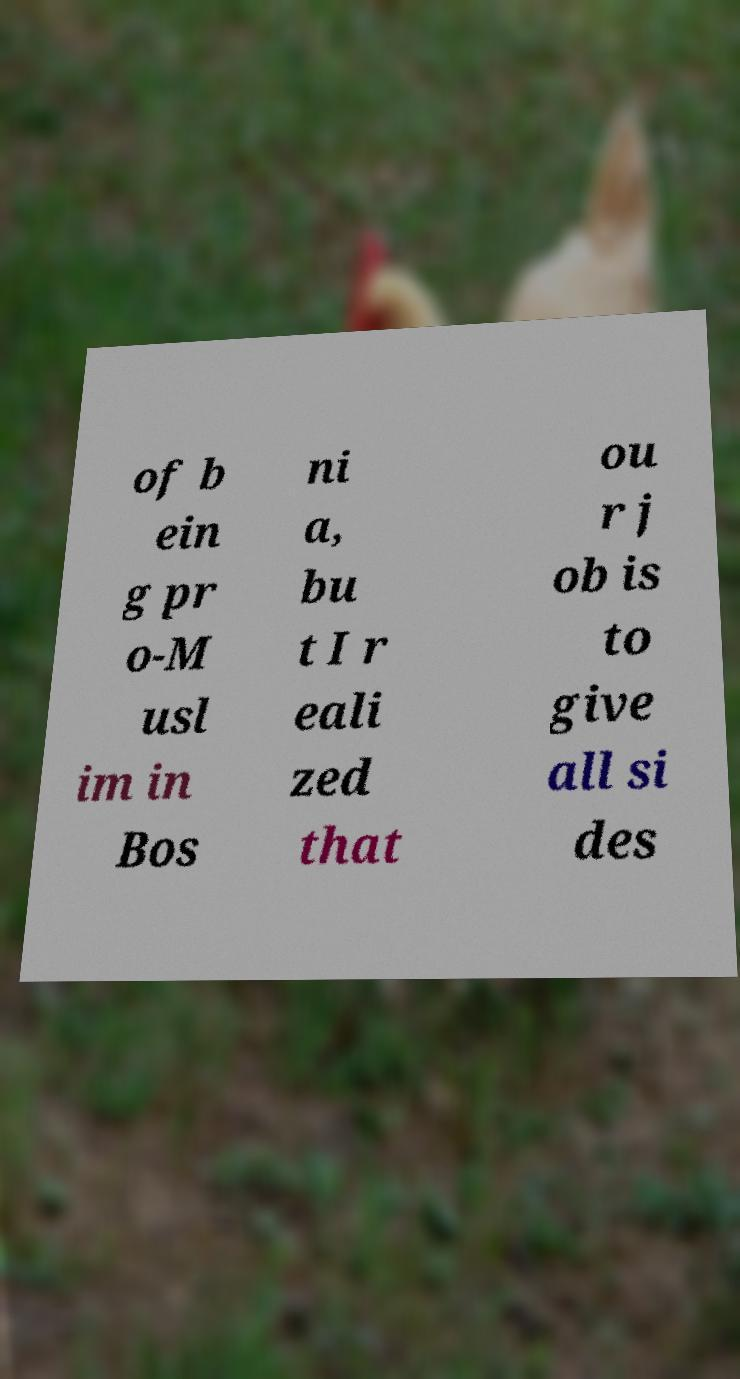Please read and relay the text visible in this image. What does it say? of b ein g pr o-M usl im in Bos ni a, bu t I r eali zed that ou r j ob is to give all si des 